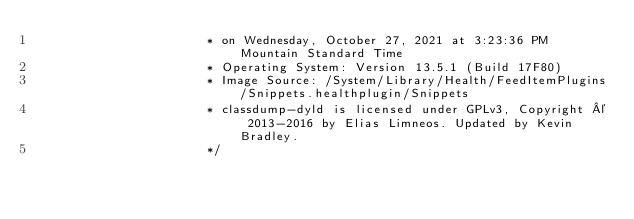<code> <loc_0><loc_0><loc_500><loc_500><_C_>                       * on Wednesday, October 27, 2021 at 3:23:36 PM Mountain Standard Time
                       * Operating System: Version 13.5.1 (Build 17F80)
                       * Image Source: /System/Library/Health/FeedItemPlugins/Snippets.healthplugin/Snippets
                       * classdump-dyld is licensed under GPLv3, Copyright © 2013-2016 by Elias Limneos. Updated by Kevin Bradley.
                       */
</code> 